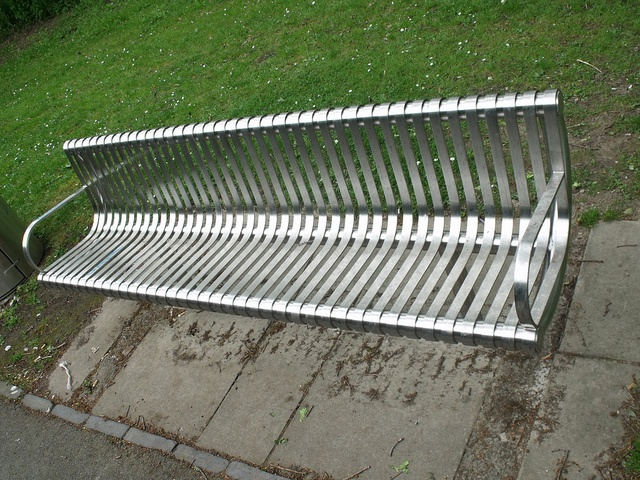Describe the objects in this image and their specific colors. I can see a bench in black, gray, lightgray, and darkgray tones in this image. 